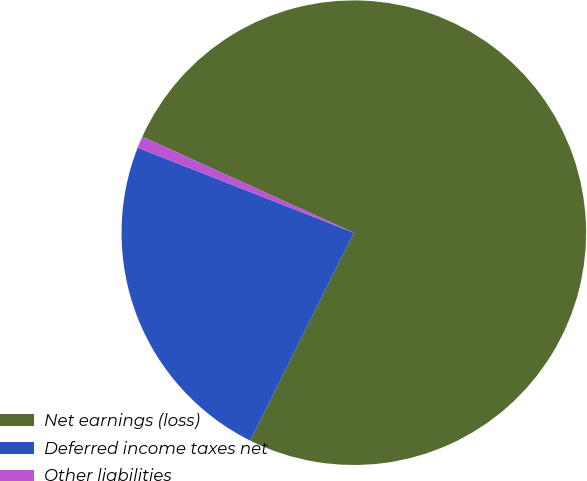Convert chart. <chart><loc_0><loc_0><loc_500><loc_500><pie_chart><fcel>Net earnings (loss)<fcel>Deferred income taxes net<fcel>Other liabilities<nl><fcel>75.57%<fcel>23.61%<fcel>0.82%<nl></chart> 